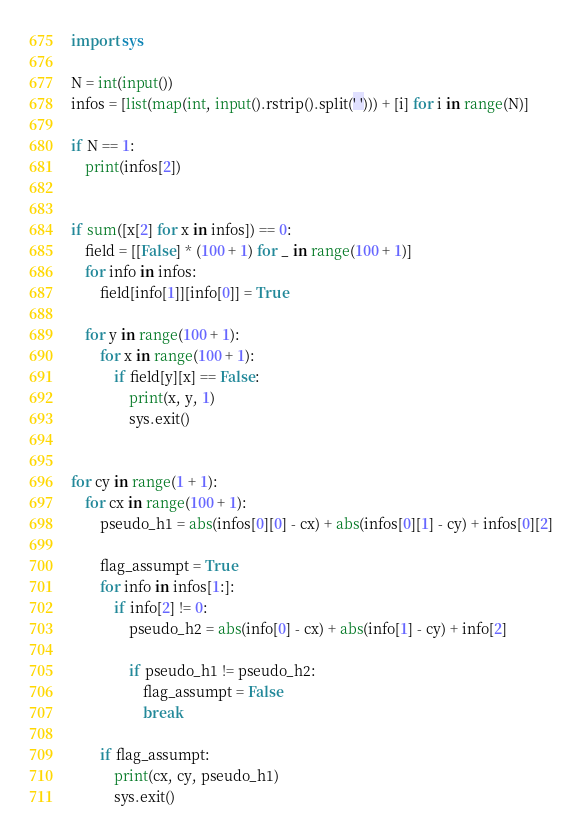<code> <loc_0><loc_0><loc_500><loc_500><_Python_>import sys
 
N = int(input())
infos = [list(map(int, input().rstrip().split(' '))) + [i] for i in range(N)]

if N == 1:
    print(infos[2])


if sum([x[2] for x in infos]) == 0:
    field = [[False] * (100 + 1) for _ in range(100 + 1)]
    for info in infos:
        field[info[1]][info[0]] = True
    
    for y in range(100 + 1):
        for x in range(100 + 1):
            if field[y][x] == False:
                print(x, y, 1)
                sys.exit()

 
for cy in range(1 + 1):
    for cx in range(100 + 1):
        pseudo_h1 = abs(infos[0][0] - cx) + abs(infos[0][1] - cy) + infos[0][2]
 
        flag_assumpt = True
        for info in infos[1:]:
            if info[2] != 0:
                pseudo_h2 = abs(info[0] - cx) + abs(info[1] - cy) + info[2]
     
                if pseudo_h1 != pseudo_h2:
                    flag_assumpt = False
                    break
        
        if flag_assumpt:
            print(cx, cy, pseudo_h1)
            sys.exit()</code> 